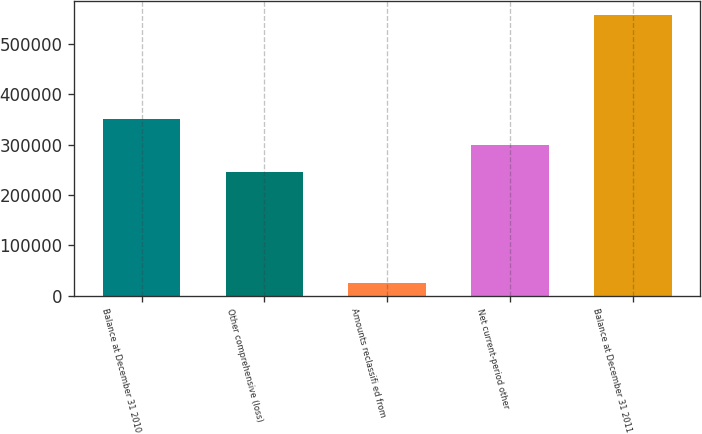<chart> <loc_0><loc_0><loc_500><loc_500><bar_chart><fcel>Balance at December 31 2010<fcel>Other comprehensive (loss)<fcel>Amounts reclassifi ed from<fcel>Net current-period other<fcel>Balance at December 31 2011<nl><fcel>351860<fcel>245394<fcel>25247<fcel>298627<fcel>557576<nl></chart> 